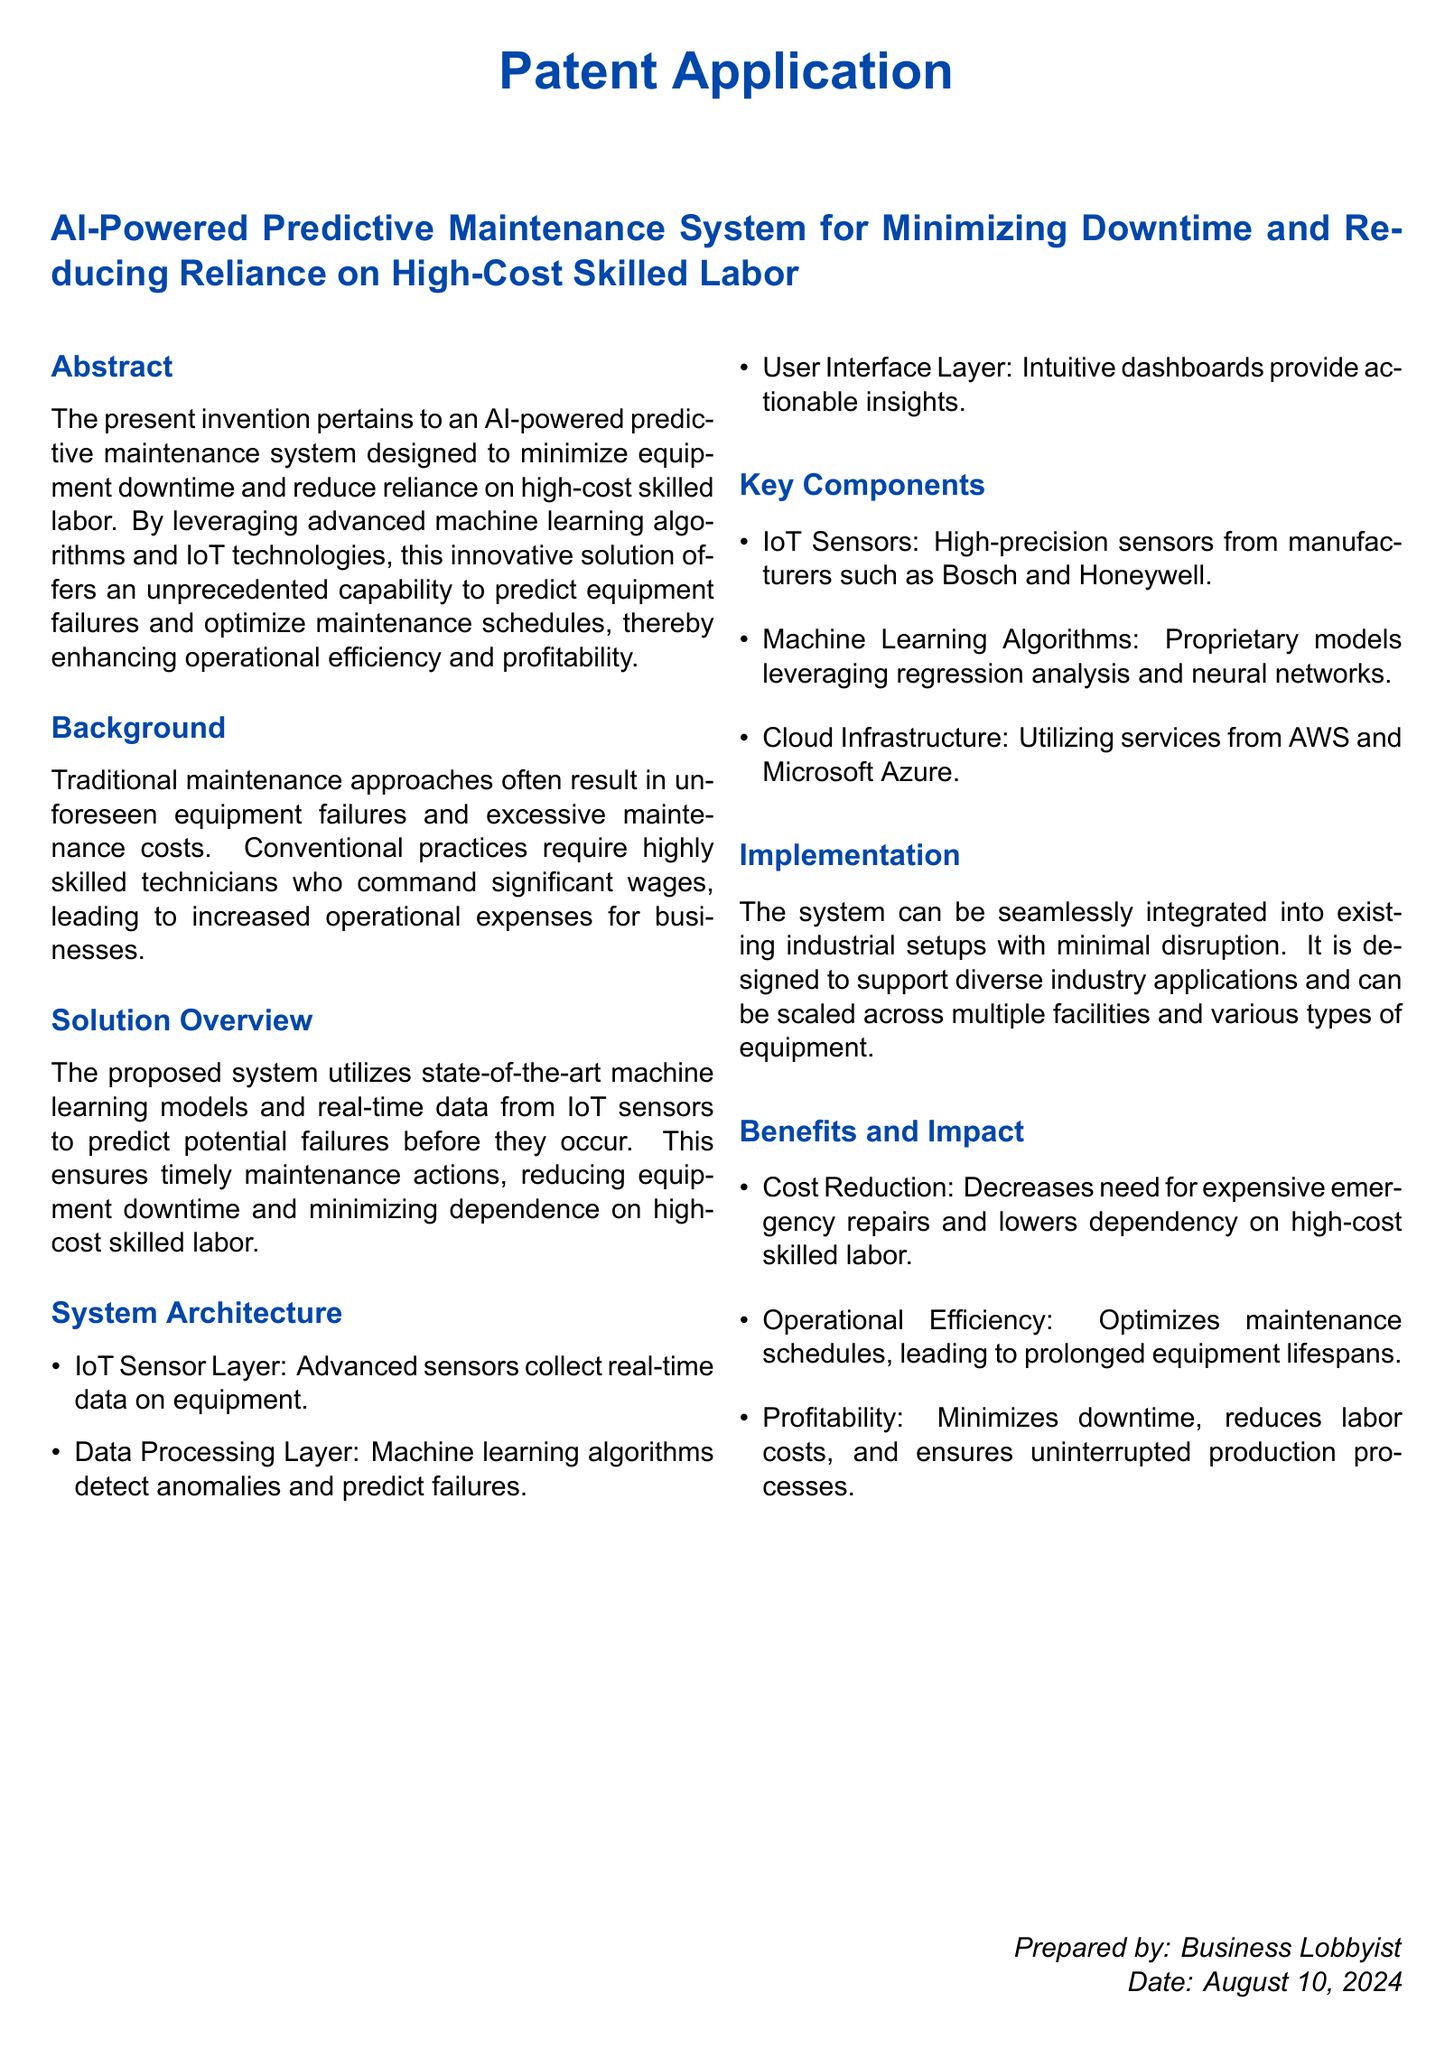what is the title of the patent application? The title of the patent application is the section header that provides the topic of the application.
Answer: AI-Powered Predictive Maintenance System for Minimizing Downtime and Reducing Reliance on High-Cost Skilled Labor what technology does the system utilize? The technology mentioned in the "Solution Overview" section includes "advanced machine learning algorithms and IoT technologies."
Answer: advanced machine learning algorithms and IoT technologies what is one key benefit mentioned in the document? The document lists multiple benefits, but one of them, as stated in the "Benefits and Impact" section, is about reducing costs.
Answer: Cost Reduction which companies are mentioned as manufacturers of IoT sensors? The document lists specific manufacturers in the "Key Components" section, mentioning companies recognized for their sensors.
Answer: Bosch and Honeywell what is the purpose of the User Interface Layer? The "System Architecture" section describes the function of each layer, including the purpose of the User Interface Layer.
Answer: Provide actionable insights how can the system be integrated into existing setups? The "Implementation" section mentions how the system can be introduced with minimal disruption.
Answer: Minimal disruption what does the proposed system predict? The "Solution Overview" section outlines the primary capability of the system in terms of predicting issues.
Answer: Equipment failures which cloud services are utilized by the system? The "Key Components" section lists specific cloud providers that the system uses for infrastructure.
Answer: AWS and Microsoft Azure how does the system impact operational efficiency? The benefits of the system related to operational efficiency are detailed in the last section; this impact is a consequence of optimized schedules.
Answer: Optimizes maintenance schedules 